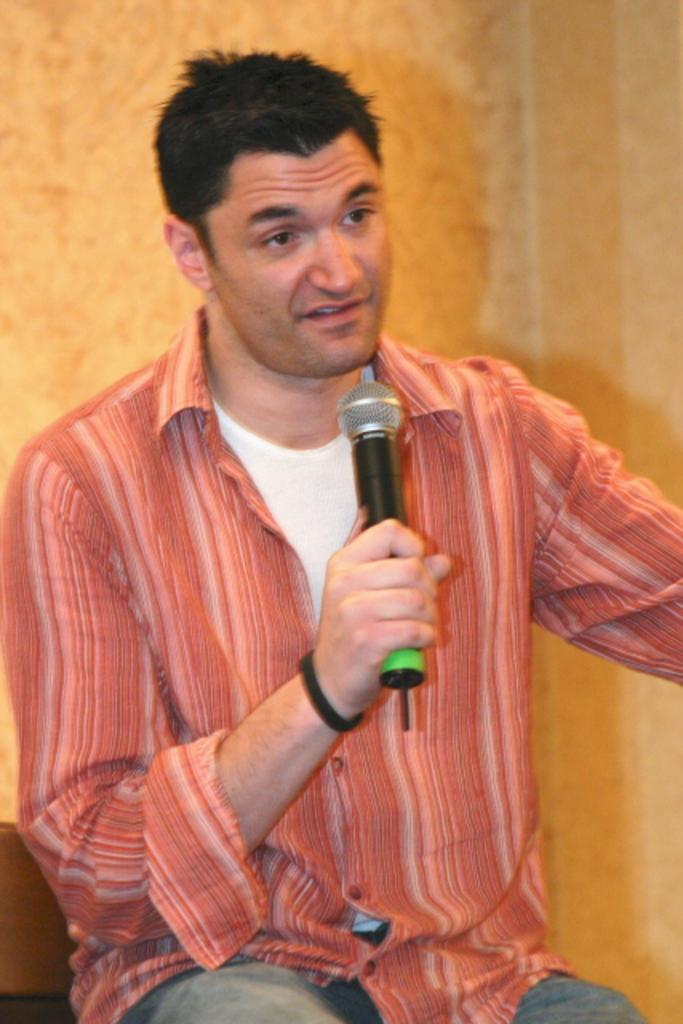Who is the main subject in the image? There is a man in the image. What is the man wearing? The man is wearing an orange shirt. What is the man holding in the image? The man is holding a microphone. What is the man doing in the image? The man is talking. What can be seen in the background of the image? There is a wall in the background of the image. How many chickens are on the man's wrist in the image? There are no chickens present in the image, and the man's wrist is not visible. 